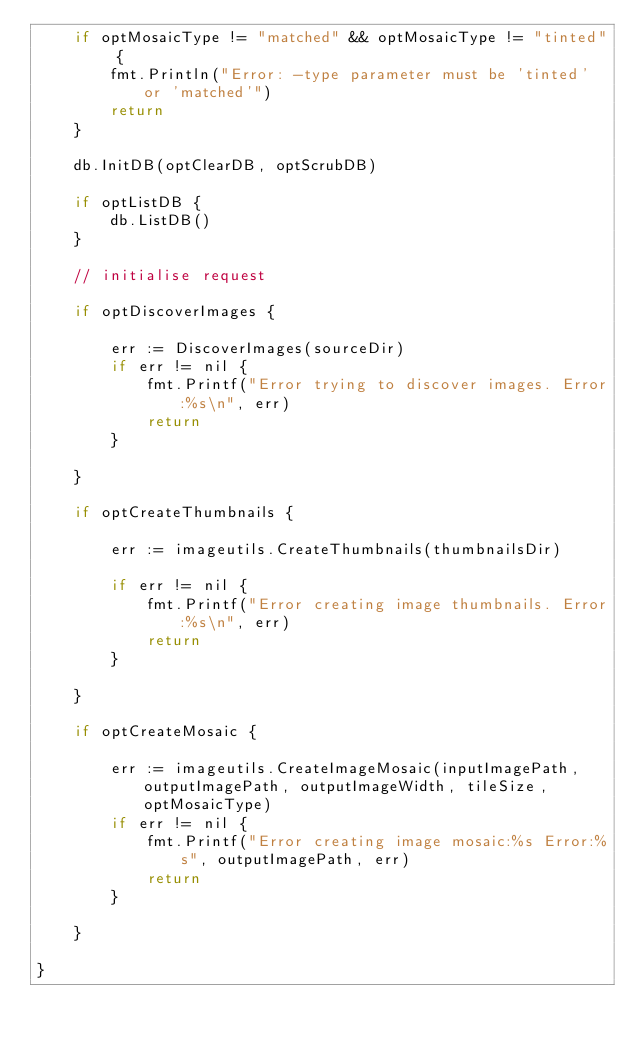Convert code to text. <code><loc_0><loc_0><loc_500><loc_500><_Go_>	if optMosaicType != "matched" && optMosaicType != "tinted" {
		fmt.Println("Error: -type parameter must be 'tinted' or 'matched'")
		return
	}

	db.InitDB(optClearDB, optScrubDB)

	if optListDB {
		db.ListDB()
	}

	// initialise request

	if optDiscoverImages {

		err := DiscoverImages(sourceDir)
		if err != nil {
			fmt.Printf("Error trying to discover images. Error:%s\n", err)
			return
		}

	}

	if optCreateThumbnails {

		err := imageutils.CreateThumbnails(thumbnailsDir)

		if err != nil {
			fmt.Printf("Error creating image thumbnails. Error:%s\n", err)
			return
		}

	}

	if optCreateMosaic {

		err := imageutils.CreateImageMosaic(inputImagePath, outputImagePath, outputImageWidth, tileSize, optMosaicType)
		if err != nil {
			fmt.Printf("Error creating image mosaic:%s Error:%s", outputImagePath, err)
			return
		}

	}

}
</code> 